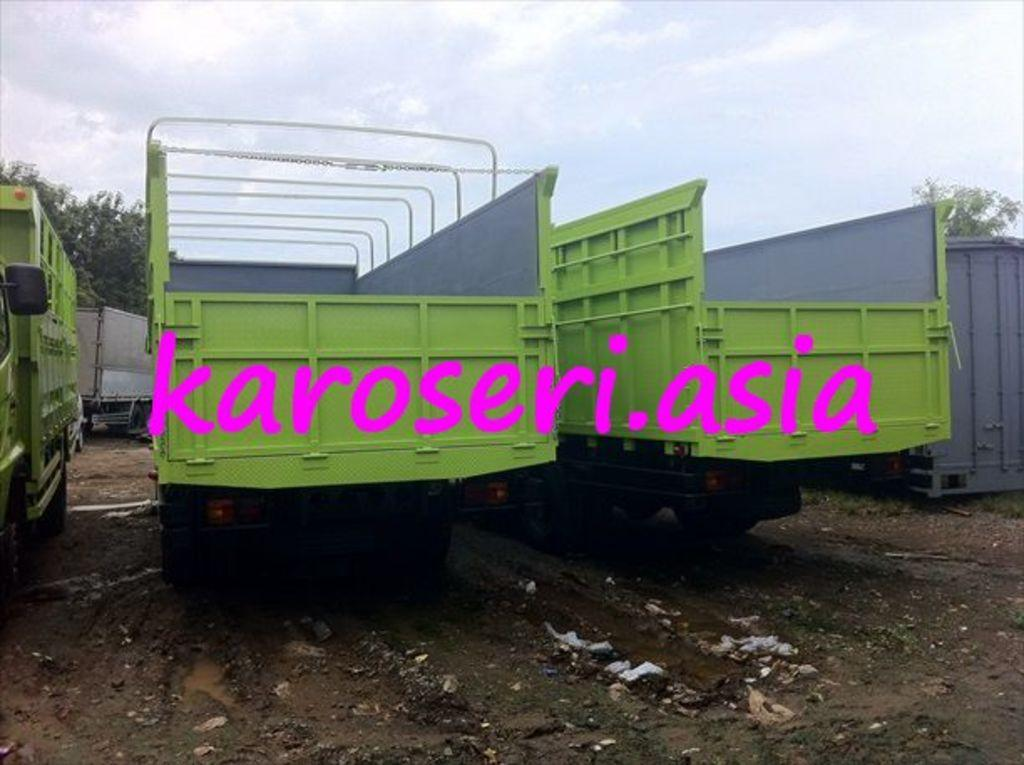What color are the trucks in the image? The trucks in the image are green. What can be seen in the background of the image? There are trees in the background of the image. What is visible at the top of the image? The sky is visible at the top of the image. What type of minister is standing on the roof of the truck in the image? There is no minister or roof present in the image; it only features green color trucks and trees in the background. 